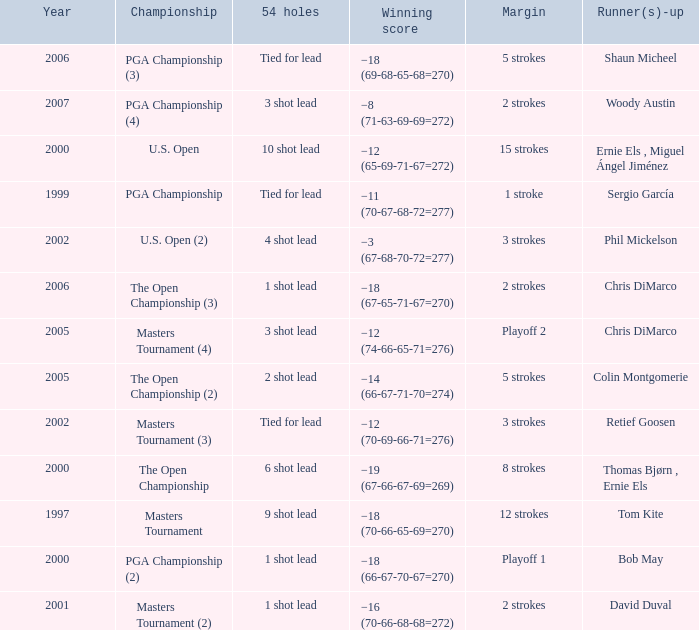What is the minimum year where winning score is −8 (71-63-69-69=272) 2007.0. 